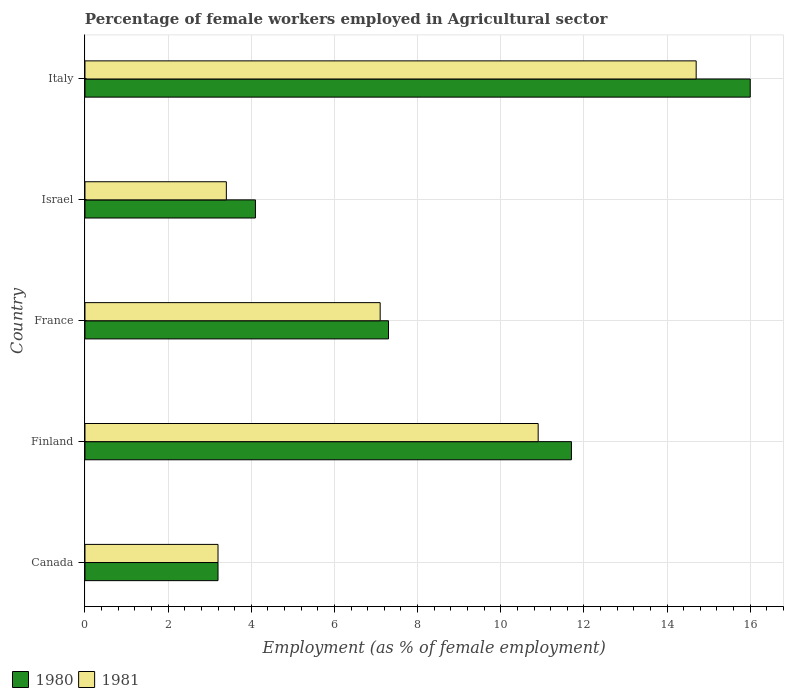How many different coloured bars are there?
Offer a terse response. 2. How many groups of bars are there?
Your answer should be very brief. 5. Are the number of bars on each tick of the Y-axis equal?
Offer a terse response. Yes. How many bars are there on the 4th tick from the top?
Provide a succinct answer. 2. In how many cases, is the number of bars for a given country not equal to the number of legend labels?
Keep it short and to the point. 0. What is the percentage of females employed in Agricultural sector in 1981 in Israel?
Give a very brief answer. 3.4. Across all countries, what is the maximum percentage of females employed in Agricultural sector in 1981?
Keep it short and to the point. 14.7. Across all countries, what is the minimum percentage of females employed in Agricultural sector in 1981?
Give a very brief answer. 3.2. In which country was the percentage of females employed in Agricultural sector in 1980 maximum?
Ensure brevity in your answer.  Italy. In which country was the percentage of females employed in Agricultural sector in 1981 minimum?
Give a very brief answer. Canada. What is the total percentage of females employed in Agricultural sector in 1980 in the graph?
Keep it short and to the point. 42.3. What is the difference between the percentage of females employed in Agricultural sector in 1980 in Finland and that in Italy?
Your answer should be compact. -4.3. What is the difference between the percentage of females employed in Agricultural sector in 1980 in Israel and the percentage of females employed in Agricultural sector in 1981 in France?
Ensure brevity in your answer.  -3. What is the average percentage of females employed in Agricultural sector in 1980 per country?
Ensure brevity in your answer.  8.46. What is the difference between the percentage of females employed in Agricultural sector in 1981 and percentage of females employed in Agricultural sector in 1980 in Finland?
Your answer should be compact. -0.8. What is the ratio of the percentage of females employed in Agricultural sector in 1980 in Canada to that in Italy?
Your answer should be very brief. 0.2. What is the difference between the highest and the second highest percentage of females employed in Agricultural sector in 1981?
Your response must be concise. 3.8. What is the difference between the highest and the lowest percentage of females employed in Agricultural sector in 1981?
Offer a terse response. 11.5. In how many countries, is the percentage of females employed in Agricultural sector in 1981 greater than the average percentage of females employed in Agricultural sector in 1981 taken over all countries?
Offer a very short reply. 2. What does the 1st bar from the bottom in Finland represents?
Offer a very short reply. 1980. How many countries are there in the graph?
Your answer should be compact. 5. What is the difference between two consecutive major ticks on the X-axis?
Offer a terse response. 2. Where does the legend appear in the graph?
Your response must be concise. Bottom left. How many legend labels are there?
Give a very brief answer. 2. What is the title of the graph?
Your answer should be compact. Percentage of female workers employed in Agricultural sector. Does "1968" appear as one of the legend labels in the graph?
Offer a terse response. No. What is the label or title of the X-axis?
Your answer should be very brief. Employment (as % of female employment). What is the Employment (as % of female employment) in 1980 in Canada?
Ensure brevity in your answer.  3.2. What is the Employment (as % of female employment) of 1981 in Canada?
Give a very brief answer. 3.2. What is the Employment (as % of female employment) of 1980 in Finland?
Keep it short and to the point. 11.7. What is the Employment (as % of female employment) in 1981 in Finland?
Your answer should be compact. 10.9. What is the Employment (as % of female employment) in 1980 in France?
Offer a terse response. 7.3. What is the Employment (as % of female employment) of 1981 in France?
Make the answer very short. 7.1. What is the Employment (as % of female employment) in 1980 in Israel?
Offer a terse response. 4.1. What is the Employment (as % of female employment) in 1981 in Israel?
Your response must be concise. 3.4. What is the Employment (as % of female employment) in 1981 in Italy?
Make the answer very short. 14.7. Across all countries, what is the maximum Employment (as % of female employment) in 1980?
Offer a terse response. 16. Across all countries, what is the maximum Employment (as % of female employment) of 1981?
Your response must be concise. 14.7. Across all countries, what is the minimum Employment (as % of female employment) in 1980?
Provide a short and direct response. 3.2. Across all countries, what is the minimum Employment (as % of female employment) of 1981?
Ensure brevity in your answer.  3.2. What is the total Employment (as % of female employment) in 1980 in the graph?
Offer a terse response. 42.3. What is the total Employment (as % of female employment) of 1981 in the graph?
Your answer should be compact. 39.3. What is the difference between the Employment (as % of female employment) in 1980 in Canada and that in Finland?
Ensure brevity in your answer.  -8.5. What is the difference between the Employment (as % of female employment) of 1981 in Canada and that in Finland?
Make the answer very short. -7.7. What is the difference between the Employment (as % of female employment) of 1980 in Canada and that in France?
Keep it short and to the point. -4.1. What is the difference between the Employment (as % of female employment) in 1981 in Canada and that in France?
Make the answer very short. -3.9. What is the difference between the Employment (as % of female employment) in 1980 in Canada and that in Italy?
Offer a terse response. -12.8. What is the difference between the Employment (as % of female employment) in 1981 in Finland and that in Israel?
Keep it short and to the point. 7.5. What is the difference between the Employment (as % of female employment) of 1981 in Finland and that in Italy?
Your answer should be very brief. -3.8. What is the difference between the Employment (as % of female employment) in 1980 in France and that in Israel?
Your answer should be very brief. 3.2. What is the difference between the Employment (as % of female employment) of 1980 in Canada and the Employment (as % of female employment) of 1981 in Israel?
Provide a succinct answer. -0.2. What is the difference between the Employment (as % of female employment) in 1980 in Canada and the Employment (as % of female employment) in 1981 in Italy?
Provide a succinct answer. -11.5. What is the difference between the Employment (as % of female employment) of 1980 in Finland and the Employment (as % of female employment) of 1981 in Israel?
Give a very brief answer. 8.3. What is the difference between the Employment (as % of female employment) of 1980 in France and the Employment (as % of female employment) of 1981 in Israel?
Give a very brief answer. 3.9. What is the difference between the Employment (as % of female employment) in 1980 in France and the Employment (as % of female employment) in 1981 in Italy?
Provide a succinct answer. -7.4. What is the difference between the Employment (as % of female employment) in 1980 in Israel and the Employment (as % of female employment) in 1981 in Italy?
Your response must be concise. -10.6. What is the average Employment (as % of female employment) in 1980 per country?
Provide a succinct answer. 8.46. What is the average Employment (as % of female employment) in 1981 per country?
Keep it short and to the point. 7.86. What is the difference between the Employment (as % of female employment) in 1980 and Employment (as % of female employment) in 1981 in Canada?
Ensure brevity in your answer.  0. What is the difference between the Employment (as % of female employment) in 1980 and Employment (as % of female employment) in 1981 in Israel?
Provide a short and direct response. 0.7. What is the difference between the Employment (as % of female employment) of 1980 and Employment (as % of female employment) of 1981 in Italy?
Your answer should be very brief. 1.3. What is the ratio of the Employment (as % of female employment) in 1980 in Canada to that in Finland?
Give a very brief answer. 0.27. What is the ratio of the Employment (as % of female employment) of 1981 in Canada to that in Finland?
Make the answer very short. 0.29. What is the ratio of the Employment (as % of female employment) in 1980 in Canada to that in France?
Make the answer very short. 0.44. What is the ratio of the Employment (as % of female employment) of 1981 in Canada to that in France?
Offer a very short reply. 0.45. What is the ratio of the Employment (as % of female employment) in 1980 in Canada to that in Israel?
Your answer should be compact. 0.78. What is the ratio of the Employment (as % of female employment) of 1981 in Canada to that in Israel?
Your response must be concise. 0.94. What is the ratio of the Employment (as % of female employment) in 1981 in Canada to that in Italy?
Provide a short and direct response. 0.22. What is the ratio of the Employment (as % of female employment) of 1980 in Finland to that in France?
Offer a very short reply. 1.6. What is the ratio of the Employment (as % of female employment) in 1981 in Finland to that in France?
Make the answer very short. 1.54. What is the ratio of the Employment (as % of female employment) in 1980 in Finland to that in Israel?
Give a very brief answer. 2.85. What is the ratio of the Employment (as % of female employment) of 1981 in Finland to that in Israel?
Your answer should be compact. 3.21. What is the ratio of the Employment (as % of female employment) of 1980 in Finland to that in Italy?
Your answer should be compact. 0.73. What is the ratio of the Employment (as % of female employment) of 1981 in Finland to that in Italy?
Give a very brief answer. 0.74. What is the ratio of the Employment (as % of female employment) in 1980 in France to that in Israel?
Offer a terse response. 1.78. What is the ratio of the Employment (as % of female employment) in 1981 in France to that in Israel?
Your answer should be compact. 2.09. What is the ratio of the Employment (as % of female employment) in 1980 in France to that in Italy?
Keep it short and to the point. 0.46. What is the ratio of the Employment (as % of female employment) of 1981 in France to that in Italy?
Your response must be concise. 0.48. What is the ratio of the Employment (as % of female employment) of 1980 in Israel to that in Italy?
Offer a very short reply. 0.26. What is the ratio of the Employment (as % of female employment) of 1981 in Israel to that in Italy?
Provide a succinct answer. 0.23. What is the difference between the highest and the lowest Employment (as % of female employment) in 1981?
Give a very brief answer. 11.5. 